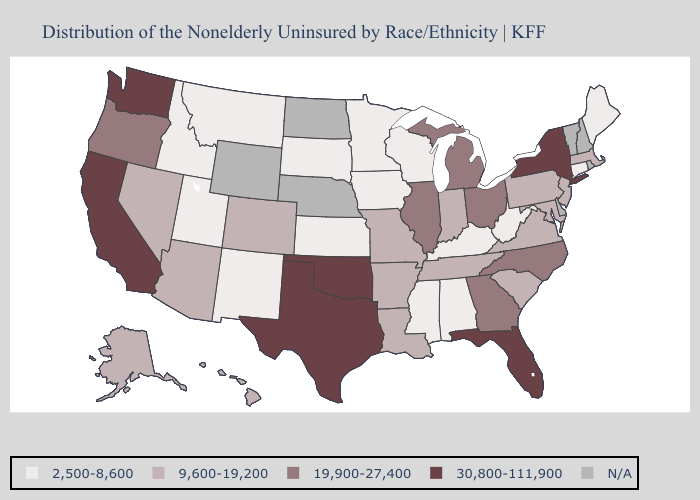Which states have the lowest value in the West?
Give a very brief answer. Idaho, Montana, New Mexico, Utah. What is the lowest value in states that border Delaware?
Give a very brief answer. 9,600-19,200. Does Connecticut have the lowest value in the Northeast?
Quick response, please. Yes. What is the highest value in the USA?
Keep it brief. 30,800-111,900. Name the states that have a value in the range 9,600-19,200?
Keep it brief. Alaska, Arizona, Arkansas, Colorado, Hawaii, Indiana, Louisiana, Maryland, Massachusetts, Missouri, Nevada, New Jersey, Pennsylvania, South Carolina, Tennessee, Virginia. What is the value of Nebraska?
Be succinct. N/A. Which states have the lowest value in the USA?
Concise answer only. Alabama, Connecticut, Idaho, Iowa, Kansas, Kentucky, Maine, Minnesota, Mississippi, Montana, New Mexico, South Dakota, Utah, West Virginia, Wisconsin. What is the highest value in states that border Idaho?
Write a very short answer. 30,800-111,900. Among the states that border Louisiana , which have the highest value?
Answer briefly. Texas. What is the value of New Jersey?
Give a very brief answer. 9,600-19,200. What is the value of Georgia?
Answer briefly. 19,900-27,400. Does the first symbol in the legend represent the smallest category?
Be succinct. Yes. What is the lowest value in the Northeast?
Short answer required. 2,500-8,600. What is the value of Tennessee?
Answer briefly. 9,600-19,200. 